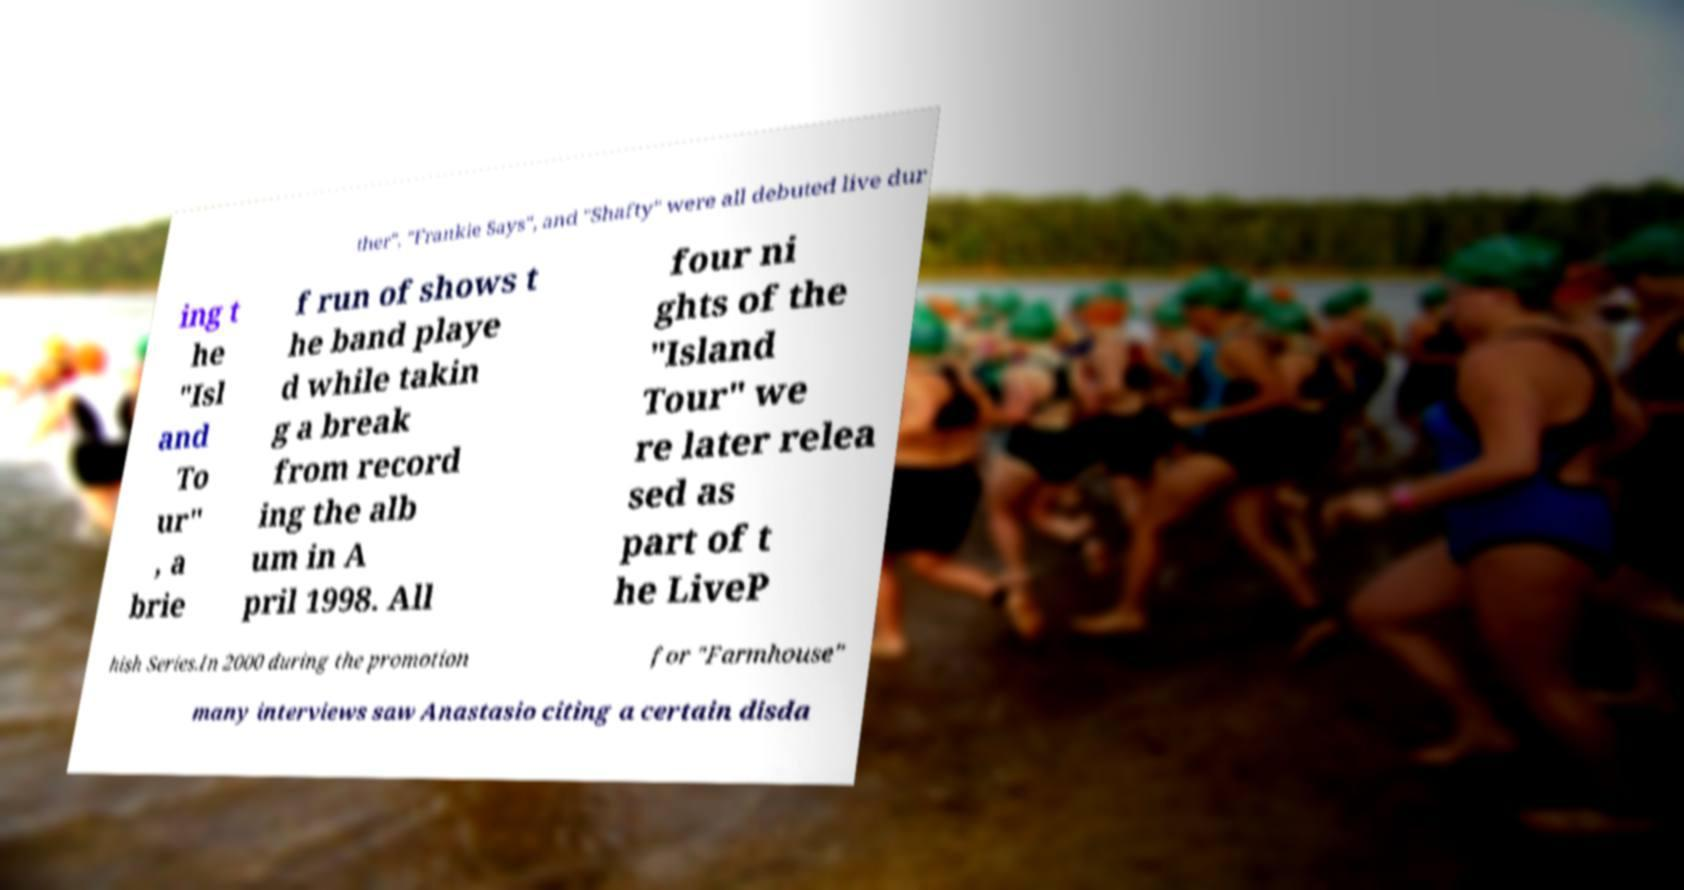Could you assist in decoding the text presented in this image and type it out clearly? ther", "Frankie Says", and "Shafty" were all debuted live dur ing t he "Isl and To ur" , a brie f run of shows t he band playe d while takin g a break from record ing the alb um in A pril 1998. All four ni ghts of the "Island Tour" we re later relea sed as part of t he LiveP hish Series.In 2000 during the promotion for "Farmhouse" many interviews saw Anastasio citing a certain disda 